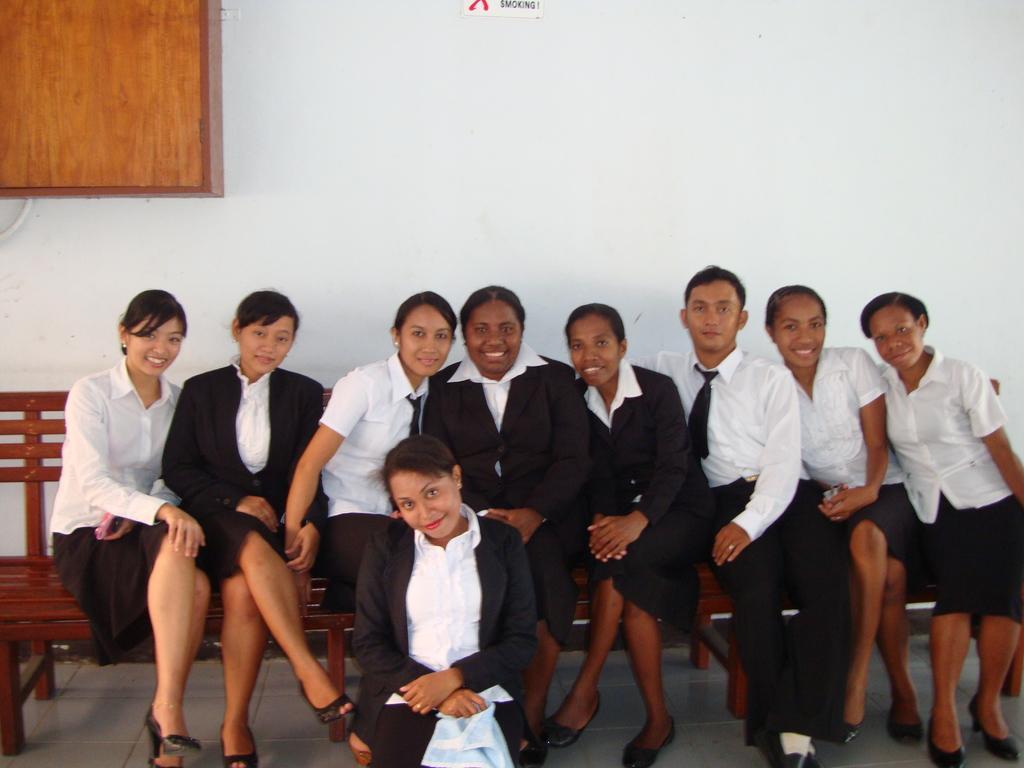How would you summarize this image in a sentence or two? In the foreground of the picture there are people sitting on a bench, in front of them there is a woman sitting on the floor. Behind them it is wall painted white. On the left there is a wooden box. 